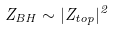<formula> <loc_0><loc_0><loc_500><loc_500>Z _ { B H } \sim | Z _ { t o p } | ^ { 2 }</formula> 